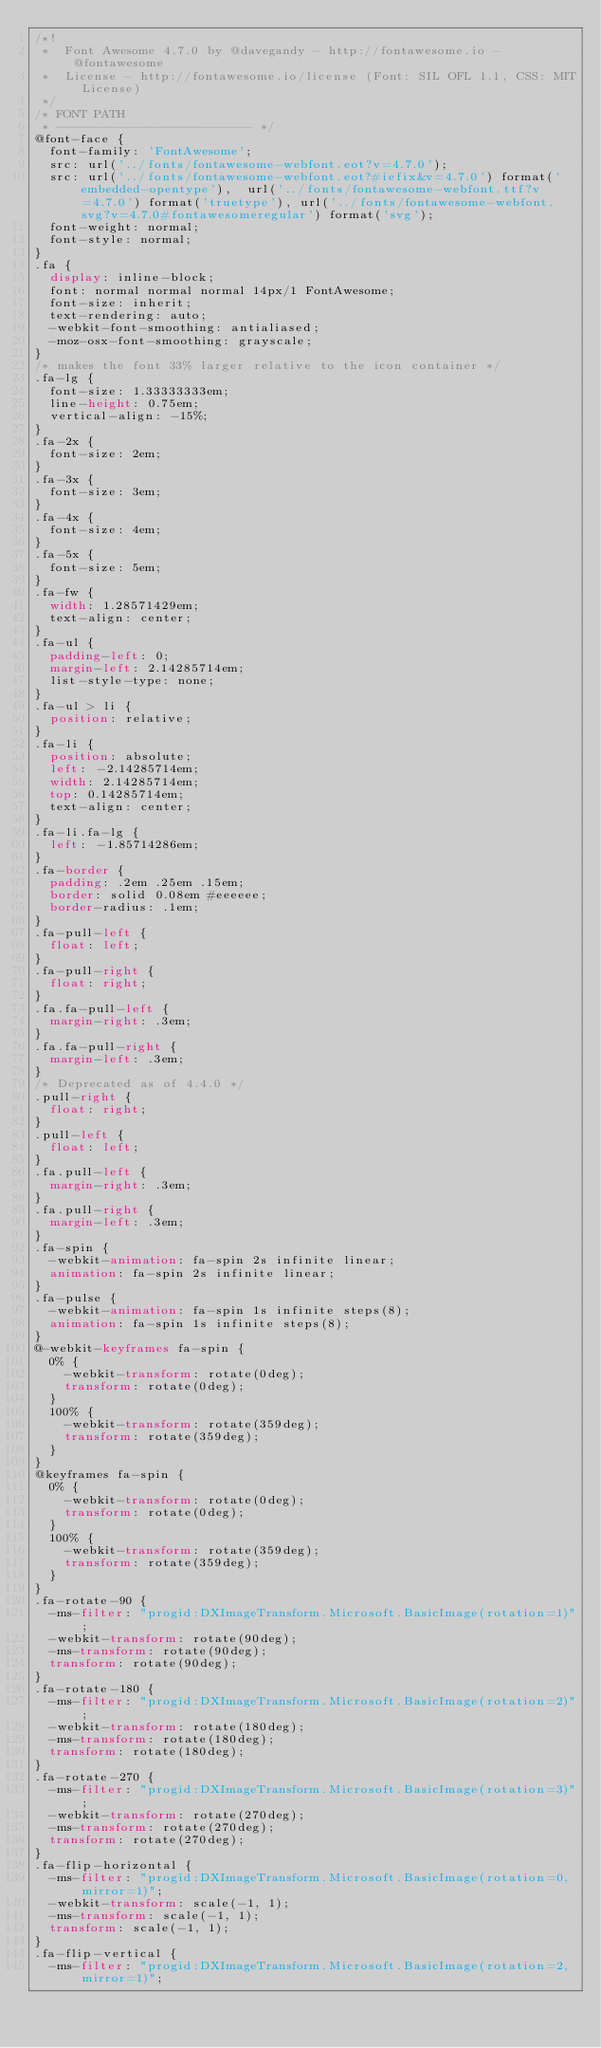<code> <loc_0><loc_0><loc_500><loc_500><_CSS_>/*!
 *  Font Awesome 4.7.0 by @davegandy - http://fontawesome.io - @fontawesome
 *  License - http://fontawesome.io/license (Font: SIL OFL 1.1, CSS: MIT License)
 */
/* FONT PATH
 * -------------------------- */
@font-face {
  font-family: 'FontAwesome';
  src: url('../fonts/fontawesome-webfont.eot?v=4.7.0');
  src: url('../fonts/fontawesome-webfont.eot?#iefix&v=4.7.0') format('embedded-opentype'),  url('../fonts/fontawesome-webfont.ttf?v=4.7.0') format('truetype'), url('../fonts/fontawesome-webfont.svg?v=4.7.0#fontawesomeregular') format('svg');
  font-weight: normal;
  font-style: normal;
}
.fa {
  display: inline-block;
  font: normal normal normal 14px/1 FontAwesome;
  font-size: inherit;
  text-rendering: auto;
  -webkit-font-smoothing: antialiased;
  -moz-osx-font-smoothing: grayscale;
}
/* makes the font 33% larger relative to the icon container */
.fa-lg {
  font-size: 1.33333333em;
  line-height: 0.75em;
  vertical-align: -15%;
}
.fa-2x {
  font-size: 2em;
}
.fa-3x {
  font-size: 3em;
}
.fa-4x {
  font-size: 4em;
}
.fa-5x {
  font-size: 5em;
}
.fa-fw {
  width: 1.28571429em;
  text-align: center;
}
.fa-ul {
  padding-left: 0;
  margin-left: 2.14285714em;
  list-style-type: none;
}
.fa-ul > li {
  position: relative;
}
.fa-li {
  position: absolute;
  left: -2.14285714em;
  width: 2.14285714em;
  top: 0.14285714em;
  text-align: center;
}
.fa-li.fa-lg {
  left: -1.85714286em;
}
.fa-border {
  padding: .2em .25em .15em;
  border: solid 0.08em #eeeeee;
  border-radius: .1em;
}
.fa-pull-left {
  float: left;
}
.fa-pull-right {
  float: right;
}
.fa.fa-pull-left {
  margin-right: .3em;
}
.fa.fa-pull-right {
  margin-left: .3em;
}
/* Deprecated as of 4.4.0 */
.pull-right {
  float: right;
}
.pull-left {
  float: left;
}
.fa.pull-left {
  margin-right: .3em;
}
.fa.pull-right {
  margin-left: .3em;
}
.fa-spin {
  -webkit-animation: fa-spin 2s infinite linear;
  animation: fa-spin 2s infinite linear;
}
.fa-pulse {
  -webkit-animation: fa-spin 1s infinite steps(8);
  animation: fa-spin 1s infinite steps(8);
}
@-webkit-keyframes fa-spin {
  0% {
    -webkit-transform: rotate(0deg);
    transform: rotate(0deg);
  }
  100% {
    -webkit-transform: rotate(359deg);
    transform: rotate(359deg);
  }
}
@keyframes fa-spin {
  0% {
    -webkit-transform: rotate(0deg);
    transform: rotate(0deg);
  }
  100% {
    -webkit-transform: rotate(359deg);
    transform: rotate(359deg);
  }
}
.fa-rotate-90 {
  -ms-filter: "progid:DXImageTransform.Microsoft.BasicImage(rotation=1)";
  -webkit-transform: rotate(90deg);
  -ms-transform: rotate(90deg);
  transform: rotate(90deg);
}
.fa-rotate-180 {
  -ms-filter: "progid:DXImageTransform.Microsoft.BasicImage(rotation=2)";
  -webkit-transform: rotate(180deg);
  -ms-transform: rotate(180deg);
  transform: rotate(180deg);
}
.fa-rotate-270 {
  -ms-filter: "progid:DXImageTransform.Microsoft.BasicImage(rotation=3)";
  -webkit-transform: rotate(270deg);
  -ms-transform: rotate(270deg);
  transform: rotate(270deg);
}
.fa-flip-horizontal {
  -ms-filter: "progid:DXImageTransform.Microsoft.BasicImage(rotation=0, mirror=1)";
  -webkit-transform: scale(-1, 1);
  -ms-transform: scale(-1, 1);
  transform: scale(-1, 1);
}
.fa-flip-vertical {
  -ms-filter: "progid:DXImageTransform.Microsoft.BasicImage(rotation=2, mirror=1)";</code> 